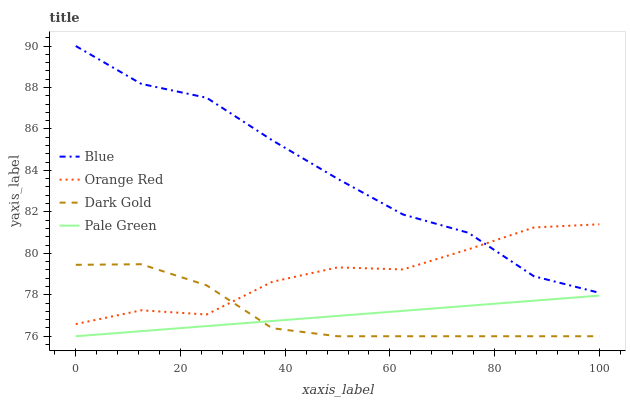Does Pale Green have the minimum area under the curve?
Answer yes or no. Yes. Does Blue have the maximum area under the curve?
Answer yes or no. Yes. Does Orange Red have the minimum area under the curve?
Answer yes or no. No. Does Orange Red have the maximum area under the curve?
Answer yes or no. No. Is Pale Green the smoothest?
Answer yes or no. Yes. Is Orange Red the roughest?
Answer yes or no. Yes. Is Orange Red the smoothest?
Answer yes or no. No. Is Pale Green the roughest?
Answer yes or no. No. Does Pale Green have the lowest value?
Answer yes or no. Yes. Does Orange Red have the lowest value?
Answer yes or no. No. Does Blue have the highest value?
Answer yes or no. Yes. Does Orange Red have the highest value?
Answer yes or no. No. Is Dark Gold less than Blue?
Answer yes or no. Yes. Is Blue greater than Pale Green?
Answer yes or no. Yes. Does Orange Red intersect Blue?
Answer yes or no. Yes. Is Orange Red less than Blue?
Answer yes or no. No. Is Orange Red greater than Blue?
Answer yes or no. No. Does Dark Gold intersect Blue?
Answer yes or no. No. 